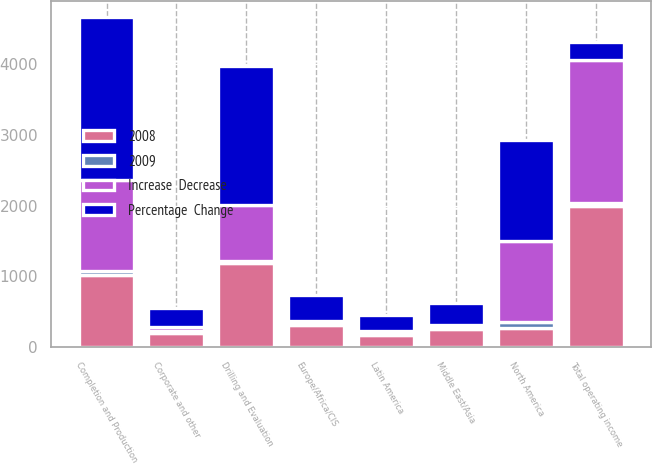<chart> <loc_0><loc_0><loc_500><loc_500><stacked_bar_chart><ecel><fcel>Completion and Production<fcel>Drilling and Evaluation<fcel>Corporate and other<fcel>Total operating income<fcel>North America<fcel>Latin America<fcel>Europe/Africa/CIS<fcel>Middle East/Asia<nl><fcel>2008<fcel>1016<fcel>1183<fcel>205<fcel>1994<fcel>272<fcel>172<fcel>315<fcel>257<nl><fcel>Percentage  Change<fcel>2304<fcel>1970<fcel>264<fcel>257<fcel>1426<fcel>214<fcel>360<fcel>304<nl><fcel>Increase  Decrease<fcel>1288<fcel>787<fcel>59<fcel>2016<fcel>1154<fcel>42<fcel>45<fcel>47<nl><fcel>2009<fcel>56<fcel>40<fcel>22<fcel>50<fcel>81<fcel>20<fcel>13<fcel>15<nl></chart> 